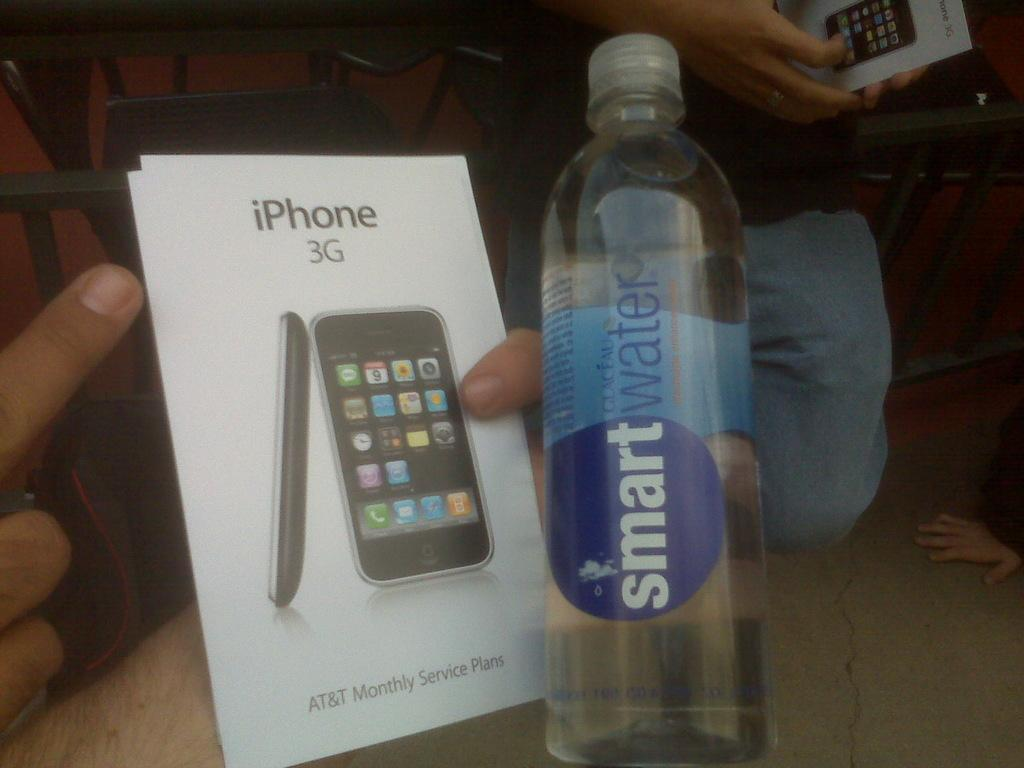<image>
Provide a brief description of the given image. IPhone 3G smartphone with smartwater to drink. Finger pointing at the Iphone 3G case. 